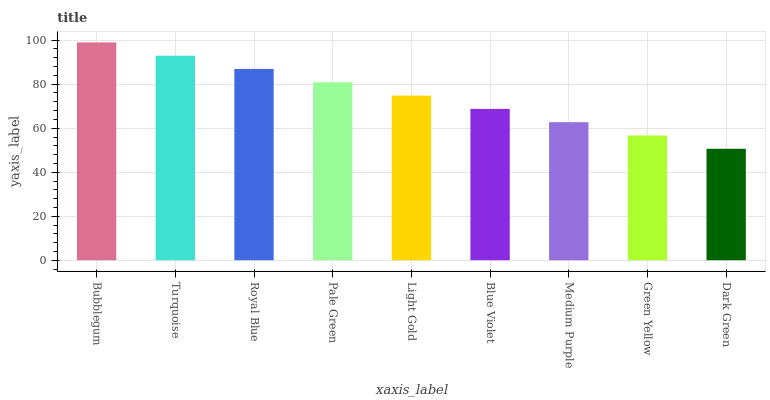Is Dark Green the minimum?
Answer yes or no. Yes. Is Bubblegum the maximum?
Answer yes or no. Yes. Is Turquoise the minimum?
Answer yes or no. No. Is Turquoise the maximum?
Answer yes or no. No. Is Bubblegum greater than Turquoise?
Answer yes or no. Yes. Is Turquoise less than Bubblegum?
Answer yes or no. Yes. Is Turquoise greater than Bubblegum?
Answer yes or no. No. Is Bubblegum less than Turquoise?
Answer yes or no. No. Is Light Gold the high median?
Answer yes or no. Yes. Is Light Gold the low median?
Answer yes or no. Yes. Is Bubblegum the high median?
Answer yes or no. No. Is Blue Violet the low median?
Answer yes or no. No. 